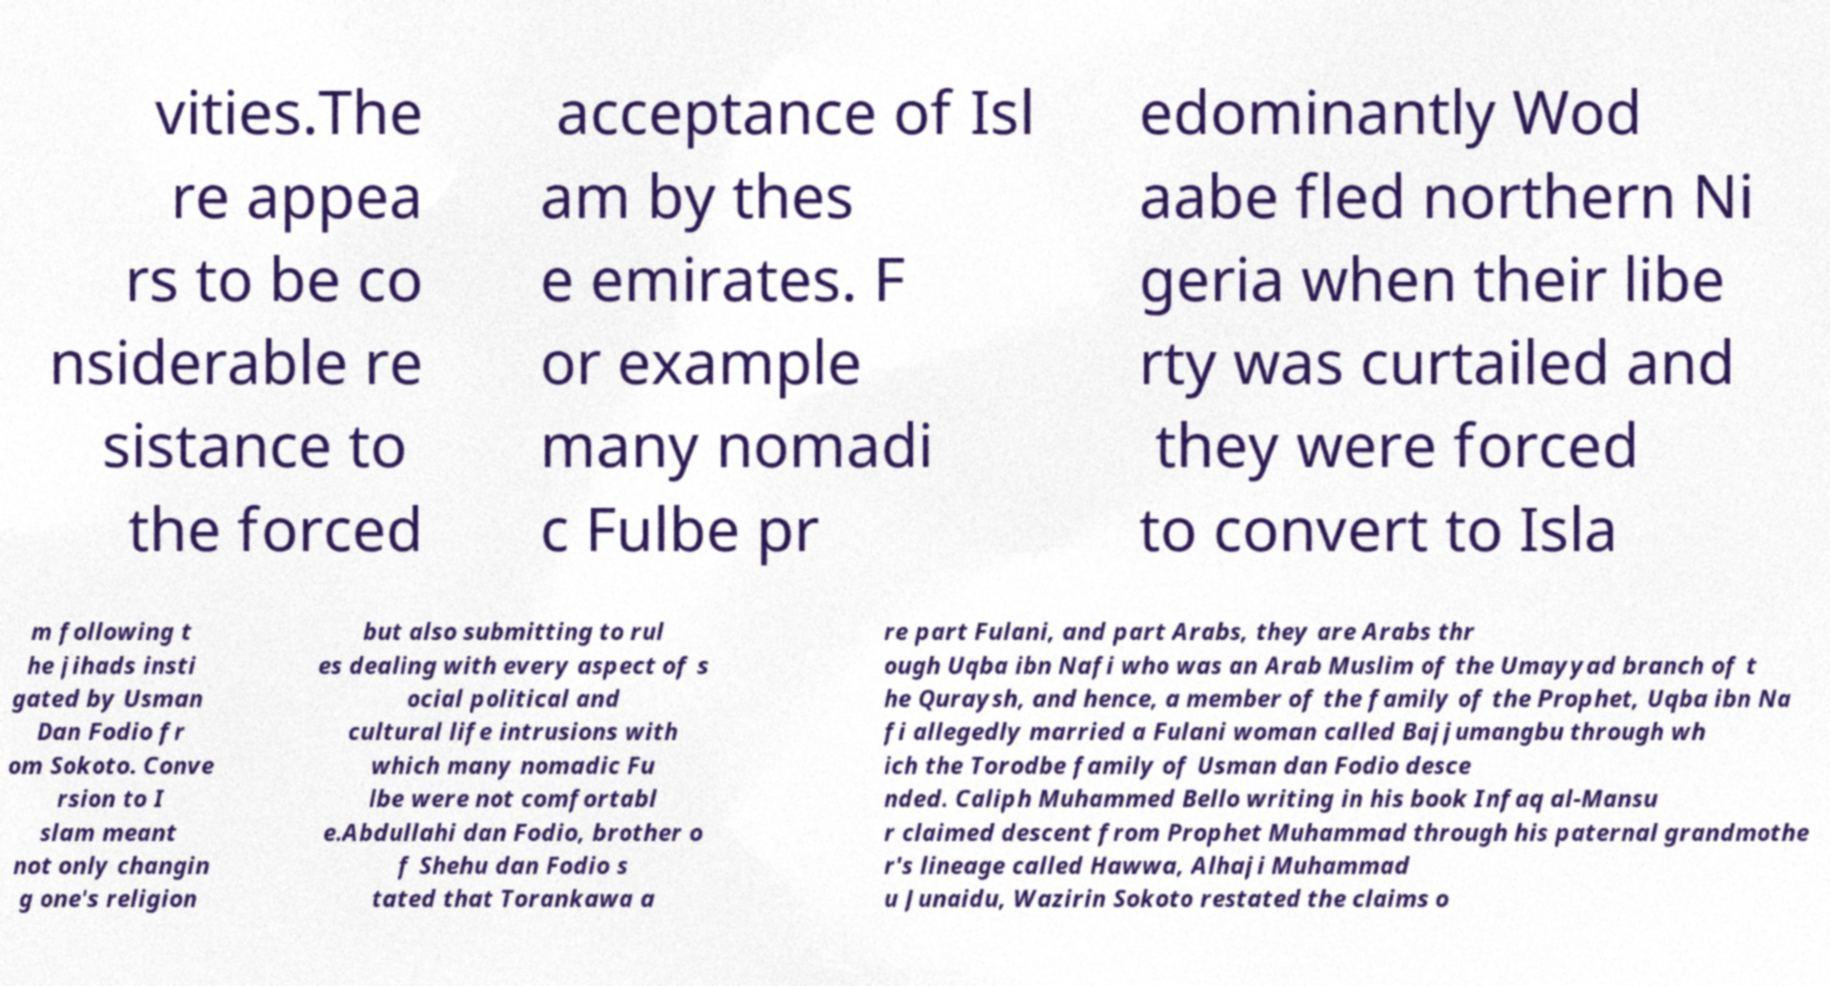Can you read and provide the text displayed in the image?This photo seems to have some interesting text. Can you extract and type it out for me? vities.The re appea rs to be co nsiderable re sistance to the forced acceptance of Isl am by thes e emirates. F or example many nomadi c Fulbe pr edominantly Wod aabe fled northern Ni geria when their libe rty was curtailed and they were forced to convert to Isla m following t he jihads insti gated by Usman Dan Fodio fr om Sokoto. Conve rsion to I slam meant not only changin g one's religion but also submitting to rul es dealing with every aspect of s ocial political and cultural life intrusions with which many nomadic Fu lbe were not comfortabl e.Abdullahi dan Fodio, brother o f Shehu dan Fodio s tated that Torankawa a re part Fulani, and part Arabs, they are Arabs thr ough Uqba ibn Nafi who was an Arab Muslim of the Umayyad branch of t he Quraysh, and hence, a member of the family of the Prophet, Uqba ibn Na fi allegedly married a Fulani woman called Bajjumangbu through wh ich the Torodbe family of Usman dan Fodio desce nded. Caliph Muhammed Bello writing in his book Infaq al-Mansu r claimed descent from Prophet Muhammad through his paternal grandmothe r's lineage called Hawwa, Alhaji Muhammad u Junaidu, Wazirin Sokoto restated the claims o 